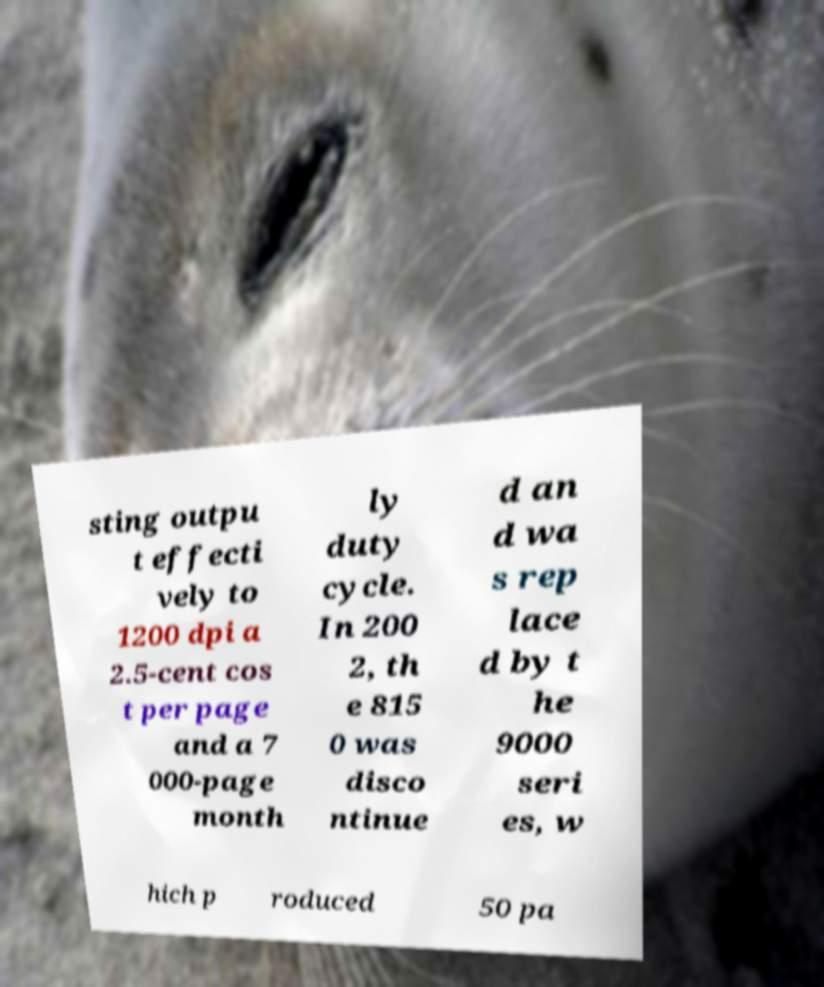Can you accurately transcribe the text from the provided image for me? sting outpu t effecti vely to 1200 dpi a 2.5-cent cos t per page and a 7 000-page month ly duty cycle. In 200 2, th e 815 0 was disco ntinue d an d wa s rep lace d by t he 9000 seri es, w hich p roduced 50 pa 